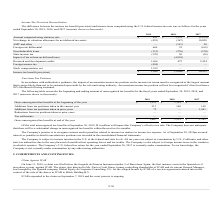According to Mitek Systems's financial document, What is the condition when an uncertain income tax position will not be recognized? if it has less than a 50% likelihood of being sustained. The document states: "ertain income tax position will not be recognized if it has less than a 50% likelihood of being sustained...." Also, How much of total unrecognized tax benefits will impact the Company’s effective tax rate on September 30, 2019? According to the financial document, $1.6 million. The relevant text states: "l unrecognized tax benefits at September 30, 2019, $1.6 million will impact the Company’s effective tax rate. The Company does not anticipate..." Also, What is the gross unrecognized tax benefit at the end of the year 2018? According to the financial document, $1,321 (in thousands). The relevant text states: "nized tax benefits at the beginning of the year $ 1,321 $ 1,181 $ —..." Also, can you calculate: What is the average gross unrecognized tax benefit at the end of the year from 2017 to 2019? To answer this question, I need to perform calculations using the financial data. The calculation is: (1,607+1,321+1,181)/3 , which equals 1369.67 (in thousands). This is based on the information: "x benefits at the beginning of the year $ 1,321 $ 1,181 $ — ss unrecognized tax benefits at end of the year $ 1,607 $ 1,321 $ 1,181 nized tax benefits at the beginning of the year $ 1,321 $ 1,181 $ —..." The key data points involved are: 1,181, 1,321, 1,607. Also, can you calculate: What is the proportion of addition from tax positions taken in the current year and prior years over gross unrecognized tax benefit at the end of the year 2019? To answer this question, I need to perform calculations using the financial data. The calculation is: (213+73)/1,607 , which equals 0.18. This is based on the information: "ions from tax positions taken in the current year 213 140 140 ss unrecognized tax benefits at end of the year $ 1,607 $ 1,321 $ 1,181 Additions from tax positions taken in prior years 73 — 1,041..." The key data points involved are: 1,607, 213, 73. Also, can you calculate: What is the percentage change in gross unrecognized tax benefits at the beginning of the year from 2018 to 2019? To answer this question, I need to perform calculations using the financial data. The calculation is: (1,321-1,181)/1,181 , which equals 11.85 (percentage). This is based on the information: "x benefits at the beginning of the year $ 1,321 $ 1,181 $ — nized tax benefits at the beginning of the year $ 1,321 $ 1,181 $ —..." The key data points involved are: 1,181, 1,321. 